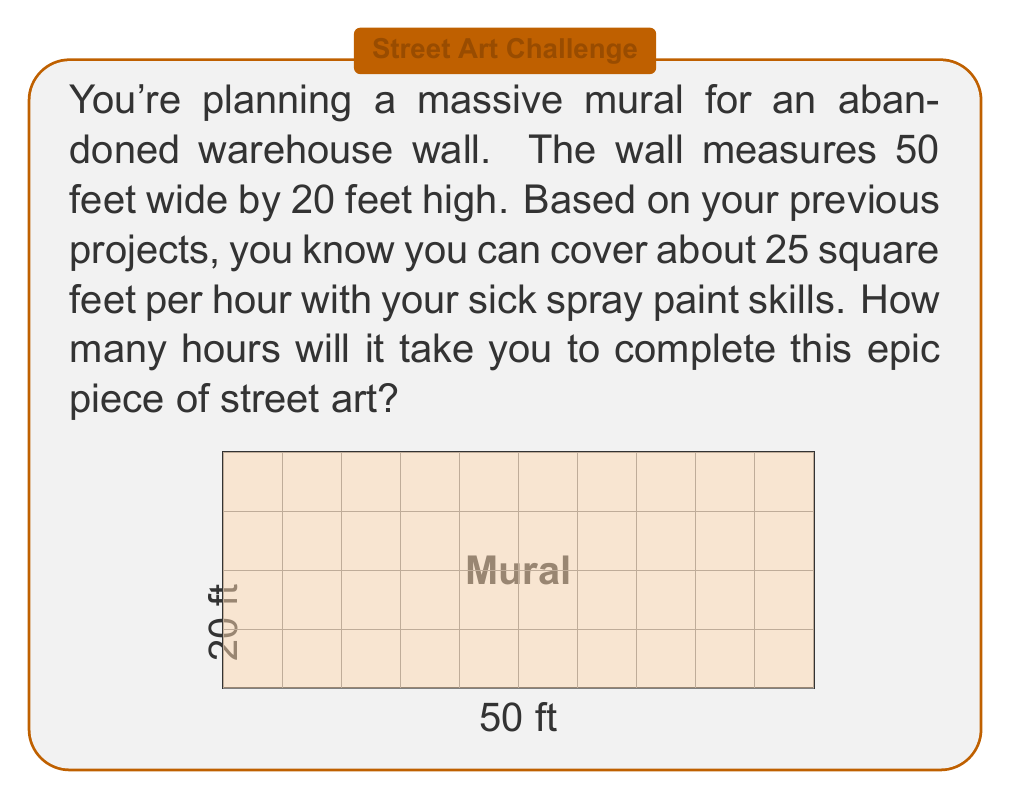Teach me how to tackle this problem. Let's break this down step by step:

1) First, we need to calculate the total area of the wall:
   $$ \text{Area} = \text{Width} \times \text{Height} $$
   $$ \text{Area} = 50 \text{ ft} \times 20 \text{ ft} = 1000 \text{ sq ft} $$

2) Now we know that you can cover 25 square feet per hour. We can express this as a rate:
   $$ \text{Rate} = 25 \text{ sq ft/hour} $$

3) To find the time, we can use the formula:
   $$ \text{Time} = \frac{\text{Total Area}}{\text{Rate}} $$

4) Plugging in our values:
   $$ \text{Time} = \frac{1000 \text{ sq ft}}{25 \text{ sq ft/hour}} $$

5) Simplifying:
   $$ \text{Time} = 40 \text{ hours} $$

So, it will take you 40 hours to complete this massive mural.
Answer: 40 hours 